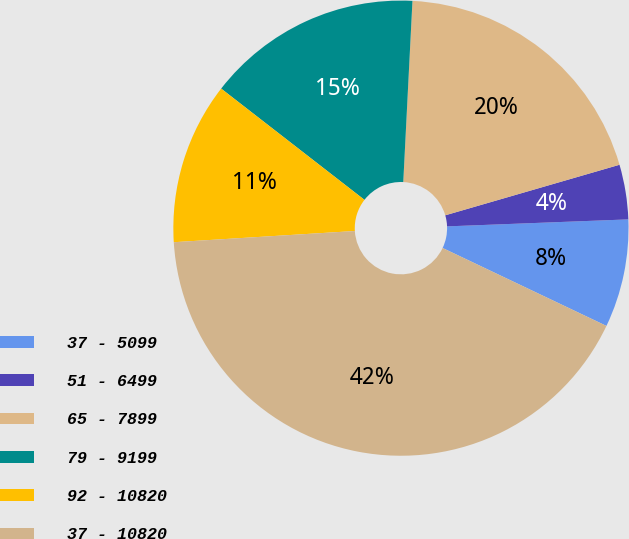Convert chart. <chart><loc_0><loc_0><loc_500><loc_500><pie_chart><fcel>37 - 5099<fcel>51 - 6499<fcel>65 - 7899<fcel>79 - 9199<fcel>92 - 10820<fcel>37 - 10820<nl><fcel>7.68%<fcel>3.88%<fcel>19.7%<fcel>15.3%<fcel>11.49%<fcel>41.95%<nl></chart> 